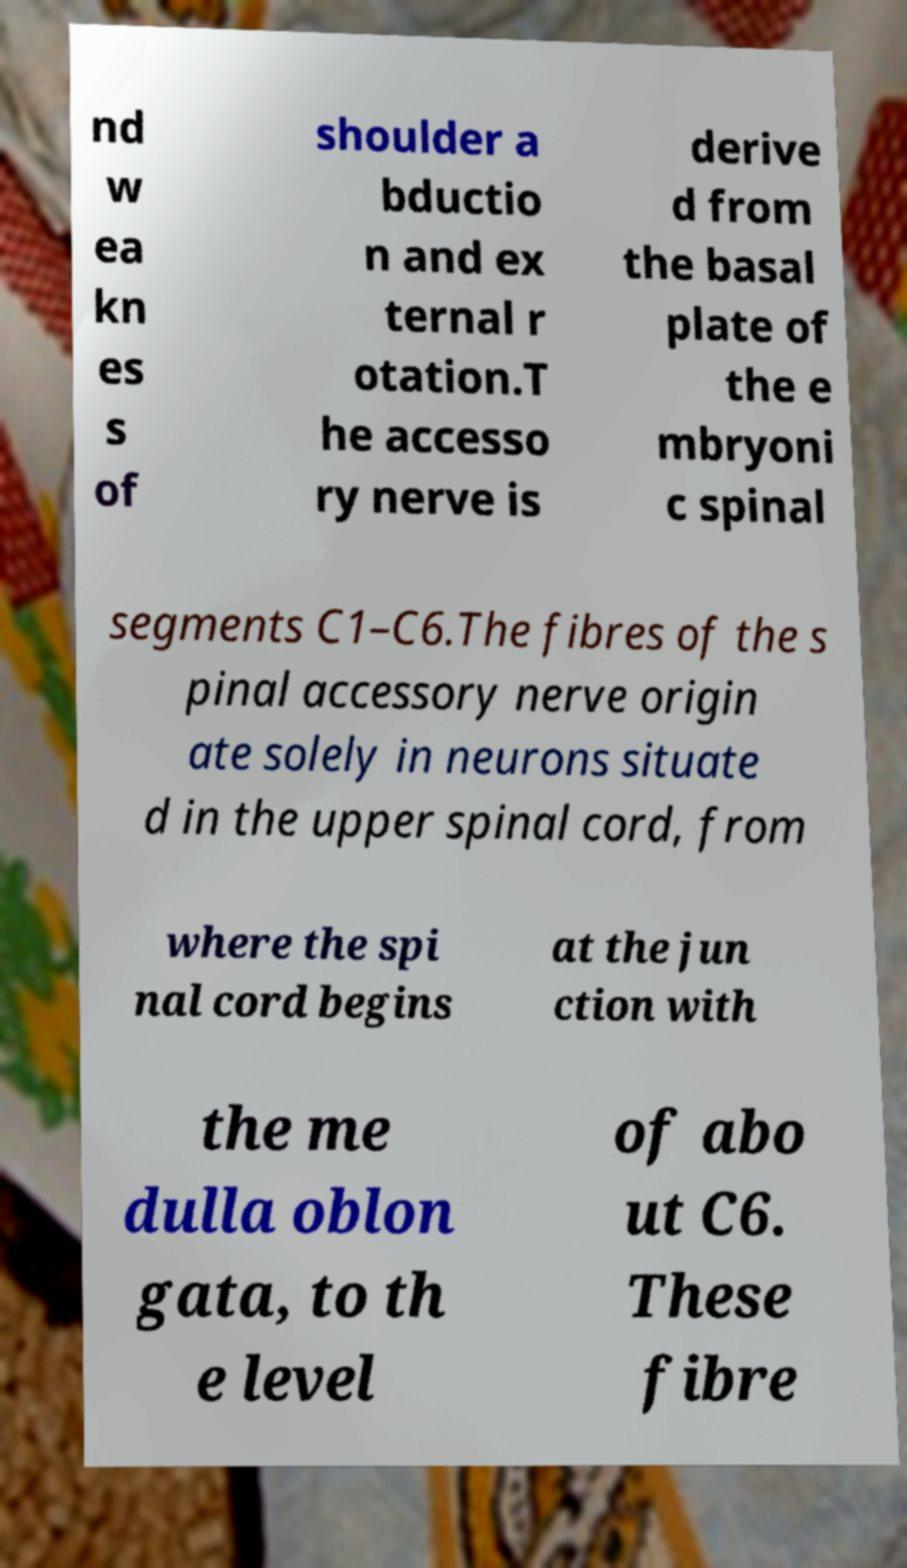Could you assist in decoding the text presented in this image and type it out clearly? nd w ea kn es s of shoulder a bductio n and ex ternal r otation.T he accesso ry nerve is derive d from the basal plate of the e mbryoni c spinal segments C1–C6.The fibres of the s pinal accessory nerve origin ate solely in neurons situate d in the upper spinal cord, from where the spi nal cord begins at the jun ction with the me dulla oblon gata, to th e level of abo ut C6. These fibre 